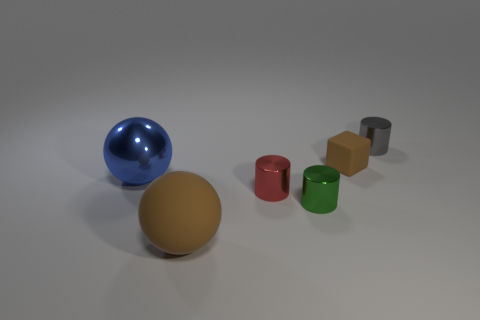If this were a scale model, can you suggest what these objects might represent? If this scene were a scale model, the spheres might represent planets or moons, whereas the cylinders could symbolize a collection of tanks or silos, perhaps for an industrial or space-themed layout. 